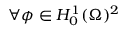<formula> <loc_0><loc_0><loc_500><loc_500>\forall \phi \in H _ { 0 } ^ { 1 } ( \Omega ) ^ { 2 }</formula> 